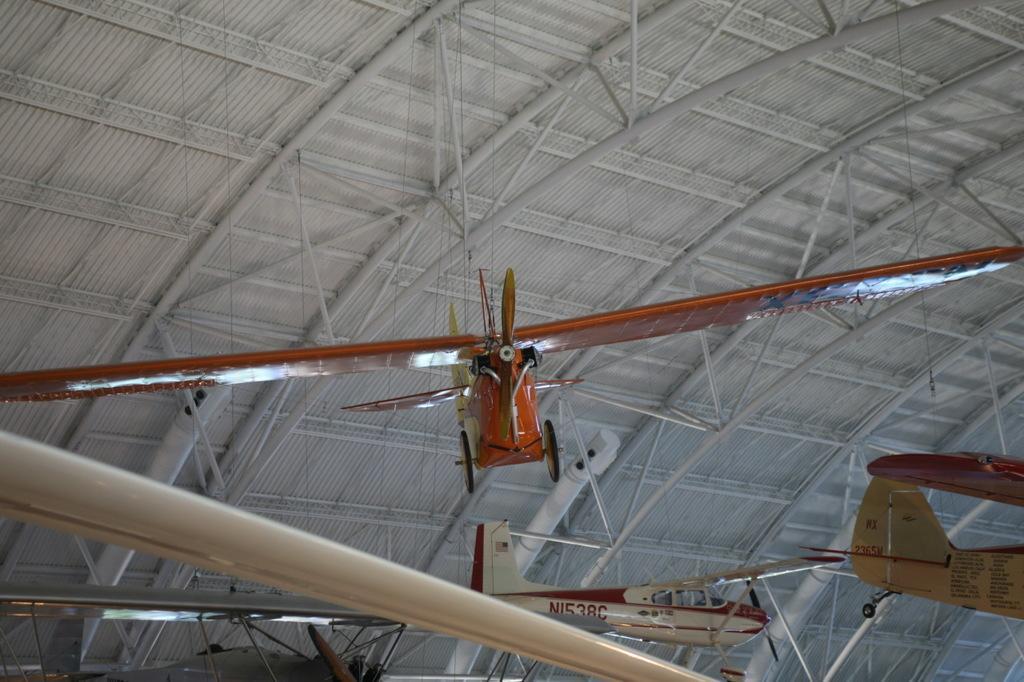Can you describe this image briefly? In this picture we can see airplanes, rods and roof. 